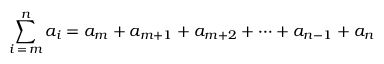<formula> <loc_0><loc_0><loc_500><loc_500>\sum _ { i = m } ^ { n } a _ { i } = a _ { m } + a _ { m + 1 } + a _ { m + 2 } + \cdots + a _ { n - 1 } + a _ { n }</formula> 